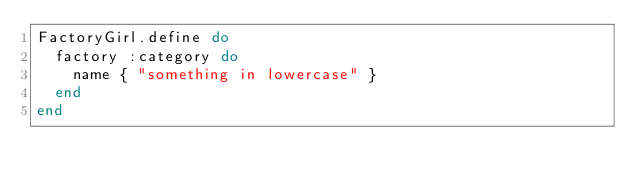Convert code to text. <code><loc_0><loc_0><loc_500><loc_500><_Ruby_>FactoryGirl.define do
  factory :category do
    name { "something in lowercase" }
  end
end
</code> 